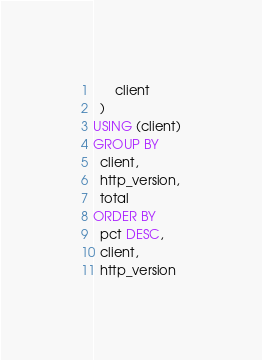<code> <loc_0><loc_0><loc_500><loc_500><_SQL_>      client
  )
USING (client)
GROUP BY
  client,
  http_version,
  total
ORDER BY
  pct DESC,
  client,
  http_version
</code> 